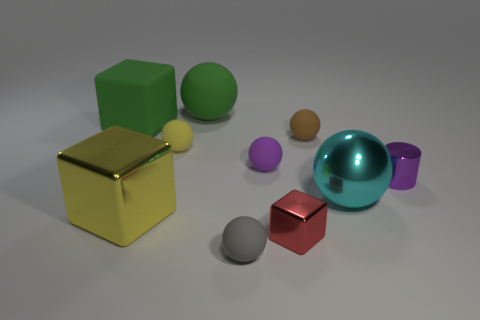Subtract all brown spheres. How many spheres are left? 5 Subtract all tiny purple spheres. How many spheres are left? 5 Subtract all cyan balls. Subtract all green blocks. How many balls are left? 5 Subtract all balls. How many objects are left? 4 Subtract 0 blue balls. How many objects are left? 10 Subtract all gray matte objects. Subtract all cylinders. How many objects are left? 8 Add 6 cylinders. How many cylinders are left? 7 Add 3 tiny red objects. How many tiny red objects exist? 4 